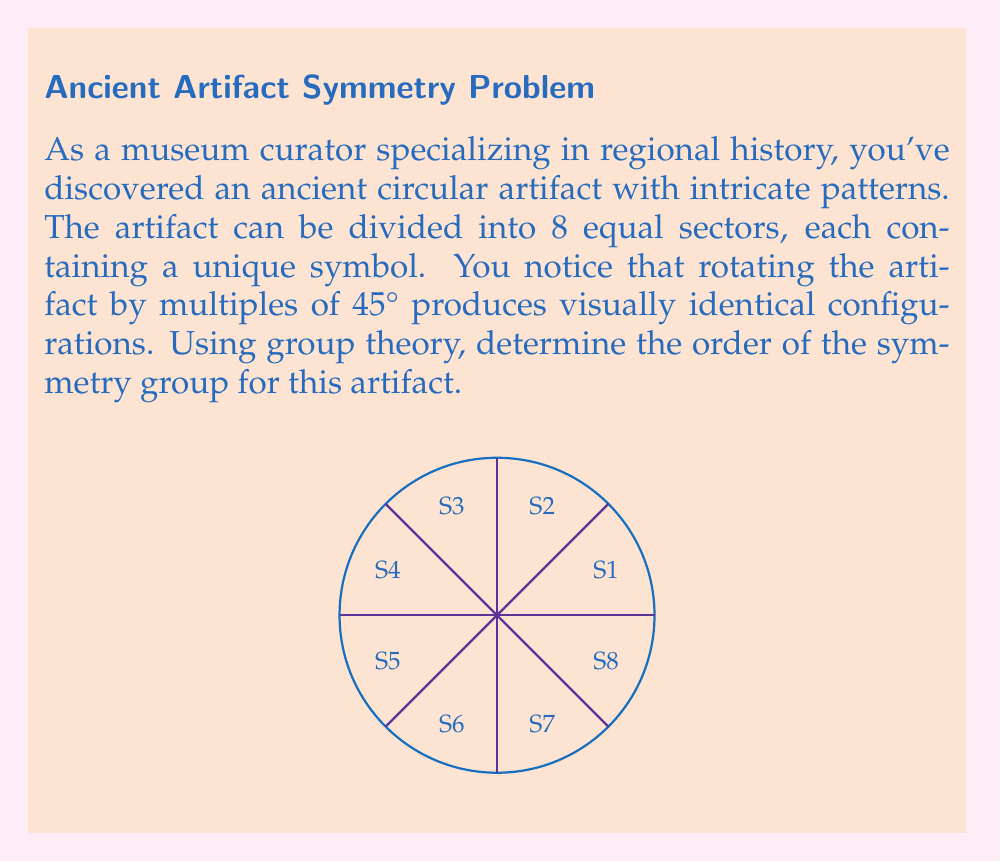Could you help me with this problem? Let's approach this step-by-step using group theory:

1) The symmetry group of this artifact is a subgroup of the dihedral group $D_8$, which includes rotations and reflections.

2) We're told that rotations by multiples of 45° produce identical configurations. This means we have rotational symmetry of order 8.

3) The rotations form a cyclic subgroup of order 8, generated by a rotation of 45°. Let's call this rotation $r$. The elements of this subgroup are:
   $\{e, r, r^2, r^3, r^4, r^5, r^6, r^7\}$
   where $e$ is the identity (no rotation).

4) We're not given information about reflections, so we can't assume the artifact has reflection symmetry.

5) Therefore, the symmetry group of this artifact is isomorphic to the cyclic group $C_8$.

6) The order of a group is the number of elements in the group. For $C_8$, this is 8.

Thus, the order of the symmetry group for this artifact is 8.
Answer: 8 